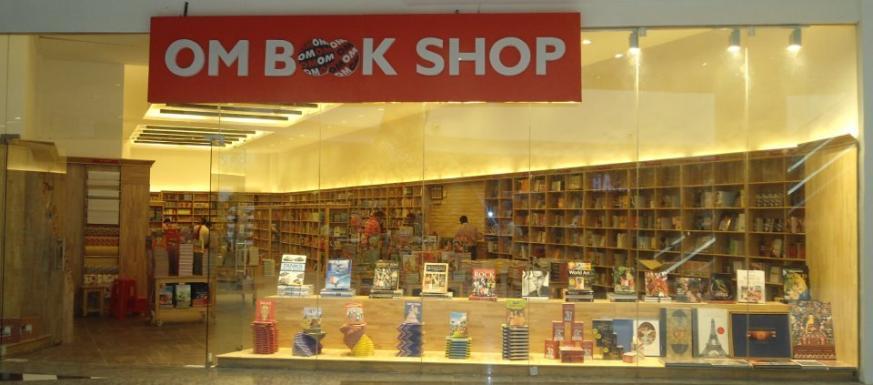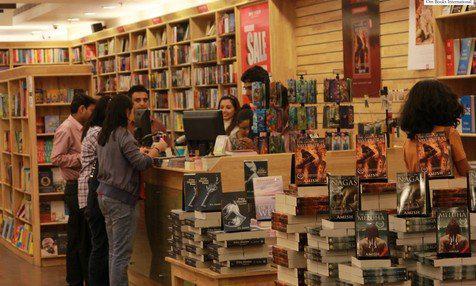The first image is the image on the left, the second image is the image on the right. Assess this claim about the two images: "One bookshop interior features a dimensional tiered display of books in front of aisles of book shelves and an exposed beam ceiling with dome-shaped lights.". Correct or not? Answer yes or no. No. The first image is the image on the left, the second image is the image on the right. For the images displayed, is the sentence "The name of the store is visible in exactly one of the images." factually correct? Answer yes or no. Yes. 